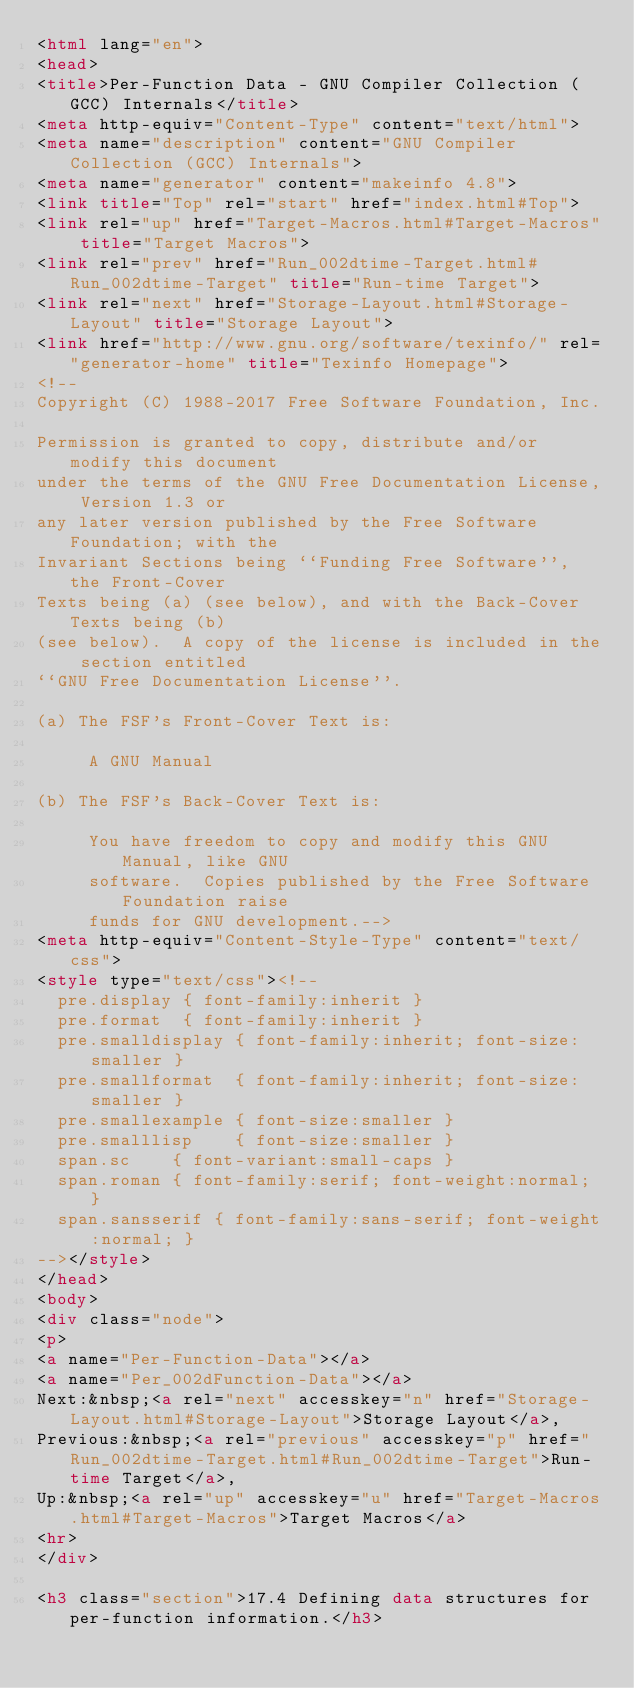<code> <loc_0><loc_0><loc_500><loc_500><_HTML_><html lang="en">
<head>
<title>Per-Function Data - GNU Compiler Collection (GCC) Internals</title>
<meta http-equiv="Content-Type" content="text/html">
<meta name="description" content="GNU Compiler Collection (GCC) Internals">
<meta name="generator" content="makeinfo 4.8">
<link title="Top" rel="start" href="index.html#Top">
<link rel="up" href="Target-Macros.html#Target-Macros" title="Target Macros">
<link rel="prev" href="Run_002dtime-Target.html#Run_002dtime-Target" title="Run-time Target">
<link rel="next" href="Storage-Layout.html#Storage-Layout" title="Storage Layout">
<link href="http://www.gnu.org/software/texinfo/" rel="generator-home" title="Texinfo Homepage">
<!--
Copyright (C) 1988-2017 Free Software Foundation, Inc.

Permission is granted to copy, distribute and/or modify this document
under the terms of the GNU Free Documentation License, Version 1.3 or
any later version published by the Free Software Foundation; with the
Invariant Sections being ``Funding Free Software'', the Front-Cover
Texts being (a) (see below), and with the Back-Cover Texts being (b)
(see below).  A copy of the license is included in the section entitled
``GNU Free Documentation License''.

(a) The FSF's Front-Cover Text is:

     A GNU Manual

(b) The FSF's Back-Cover Text is:

     You have freedom to copy and modify this GNU Manual, like GNU
     software.  Copies published by the Free Software Foundation raise
     funds for GNU development.-->
<meta http-equiv="Content-Style-Type" content="text/css">
<style type="text/css"><!--
  pre.display { font-family:inherit }
  pre.format  { font-family:inherit }
  pre.smalldisplay { font-family:inherit; font-size:smaller }
  pre.smallformat  { font-family:inherit; font-size:smaller }
  pre.smallexample { font-size:smaller }
  pre.smalllisp    { font-size:smaller }
  span.sc    { font-variant:small-caps }
  span.roman { font-family:serif; font-weight:normal; } 
  span.sansserif { font-family:sans-serif; font-weight:normal; } 
--></style>
</head>
<body>
<div class="node">
<p>
<a name="Per-Function-Data"></a>
<a name="Per_002dFunction-Data"></a>
Next:&nbsp;<a rel="next" accesskey="n" href="Storage-Layout.html#Storage-Layout">Storage Layout</a>,
Previous:&nbsp;<a rel="previous" accesskey="p" href="Run_002dtime-Target.html#Run_002dtime-Target">Run-time Target</a>,
Up:&nbsp;<a rel="up" accesskey="u" href="Target-Macros.html#Target-Macros">Target Macros</a>
<hr>
</div>

<h3 class="section">17.4 Defining data structures for per-function information.</h3>
</code> 